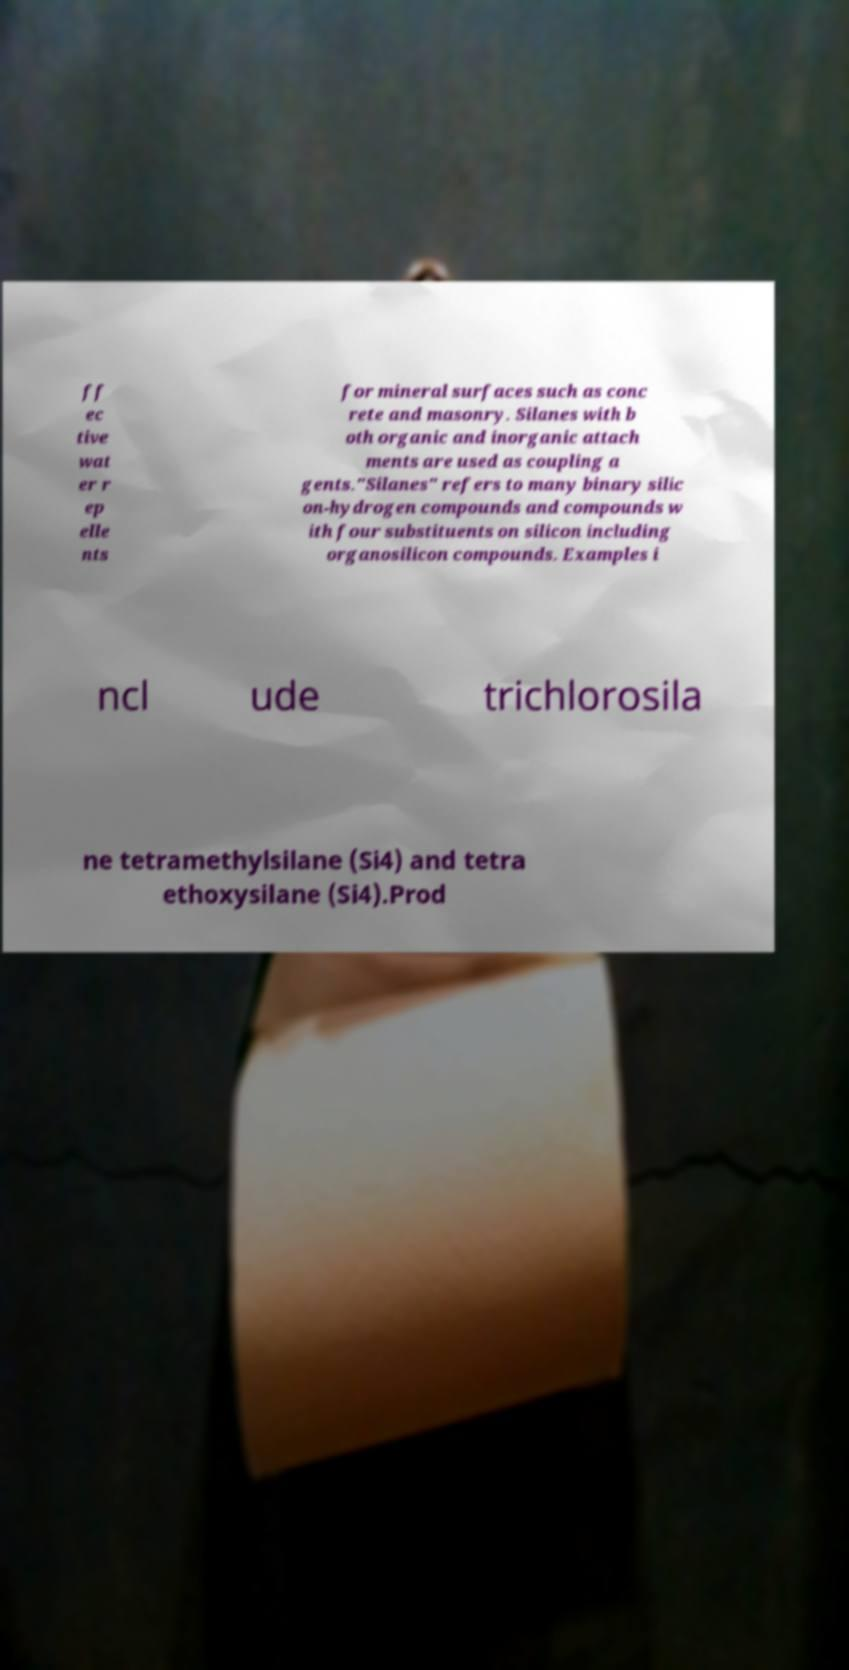Could you extract and type out the text from this image? ff ec tive wat er r ep elle nts for mineral surfaces such as conc rete and masonry. Silanes with b oth organic and inorganic attach ments are used as coupling a gents."Silanes" refers to many binary silic on-hydrogen compounds and compounds w ith four substituents on silicon including organosilicon compounds. Examples i ncl ude trichlorosila ne tetramethylsilane (Si4) and tetra ethoxysilane (Si4).Prod 